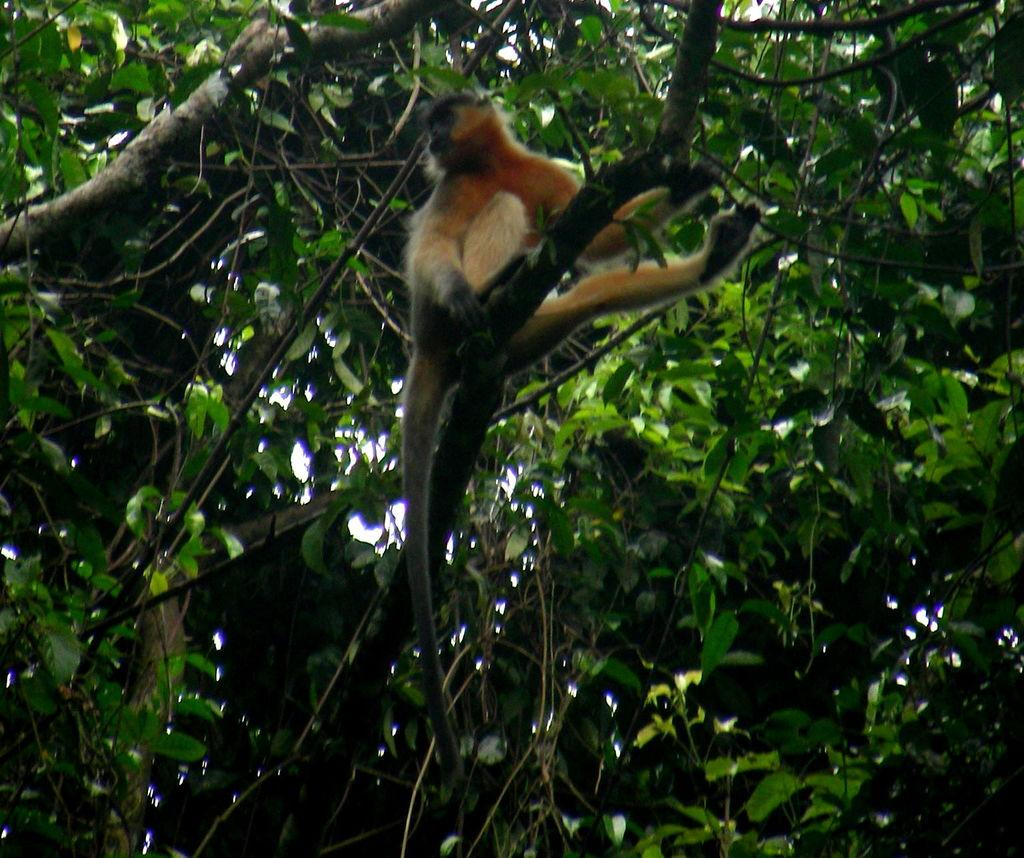What animal is present in the image? There is a monkey in the image. Where is the monkey located? The monkey is on a branch of a tree. What can be seen in the background of the image? There are branches with leaves in the background of the image. What rule does the creature follow in the image? There is no creature mentioned in the image, only a monkey. Additionally, the image does not depict any rules or behaviors. 